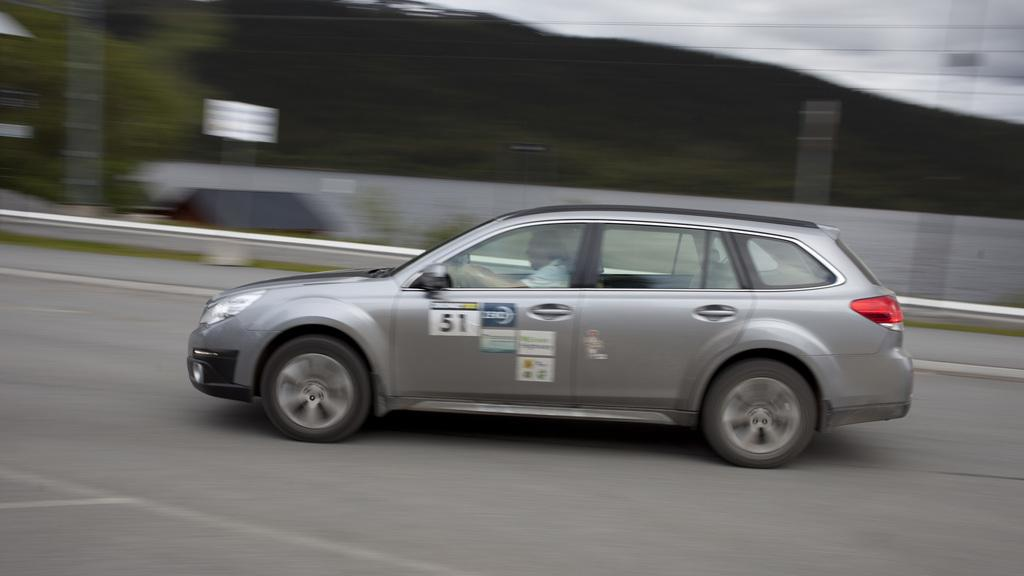What is the person in the image doing? The person is driving a vehicle in the image. Where is the vehicle located? The vehicle is on the road. Can you describe the background of the image? The background of the image is blurred, but a hill, electrical wires, and the sky are visible. What type of waste can be seen being thrown out of the vehicle in the image? There is no waste being thrown out of the vehicle in the image. Is there a bomb visible in the image? No, there is no bomb present in the image. 